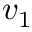<formula> <loc_0><loc_0><loc_500><loc_500>v _ { 1 }</formula> 